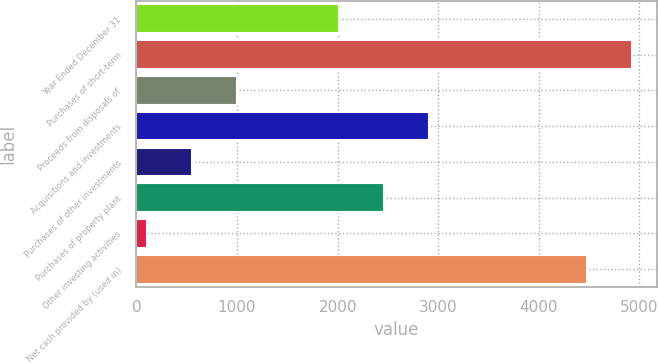Convert chart. <chart><loc_0><loc_0><loc_500><loc_500><bar_chart><fcel>Year Ended December 31<fcel>Purchases of short-term<fcel>Proceeds from disposals of<fcel>Acquisitions and investments<fcel>Purchases of other investments<fcel>Purchases of property plant<fcel>Other investing activities<fcel>Net cash provided by (used in)<nl><fcel>2010<fcel>4926.6<fcel>1000.6<fcel>2904.6<fcel>553.3<fcel>2457.3<fcel>106<fcel>4479.3<nl></chart> 